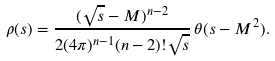Convert formula to latex. <formula><loc_0><loc_0><loc_500><loc_500>\rho ( s ) = \frac { ( \sqrt { s } - M ) ^ { n - 2 } } { 2 ( 4 \pi ) ^ { n - 1 } ( n - 2 ) ! \sqrt { s } } \, \theta ( s - M ^ { 2 } ) .</formula> 